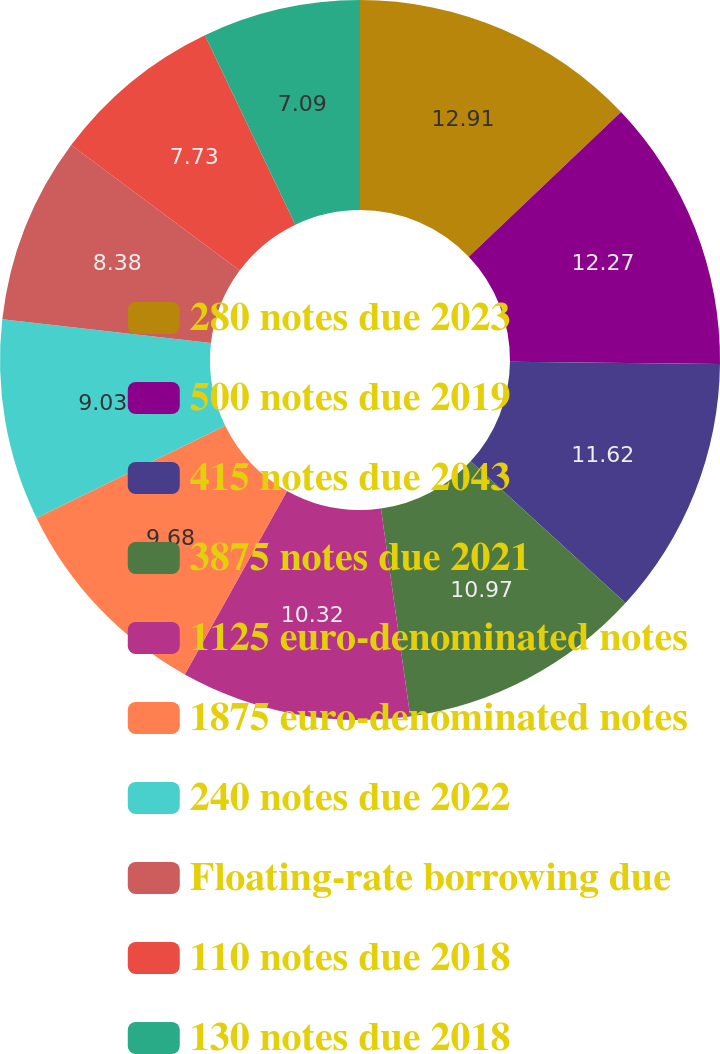Convert chart to OTSL. <chart><loc_0><loc_0><loc_500><loc_500><pie_chart><fcel>280 notes due 2023<fcel>500 notes due 2019<fcel>415 notes due 2043<fcel>3875 notes due 2021<fcel>1125 euro-denominated notes<fcel>1875 euro-denominated notes<fcel>240 notes due 2022<fcel>Floating-rate borrowing due<fcel>110 notes due 2018<fcel>130 notes due 2018<nl><fcel>12.91%<fcel>12.27%<fcel>11.62%<fcel>10.97%<fcel>10.32%<fcel>9.68%<fcel>9.03%<fcel>8.38%<fcel>7.73%<fcel>7.09%<nl></chart> 